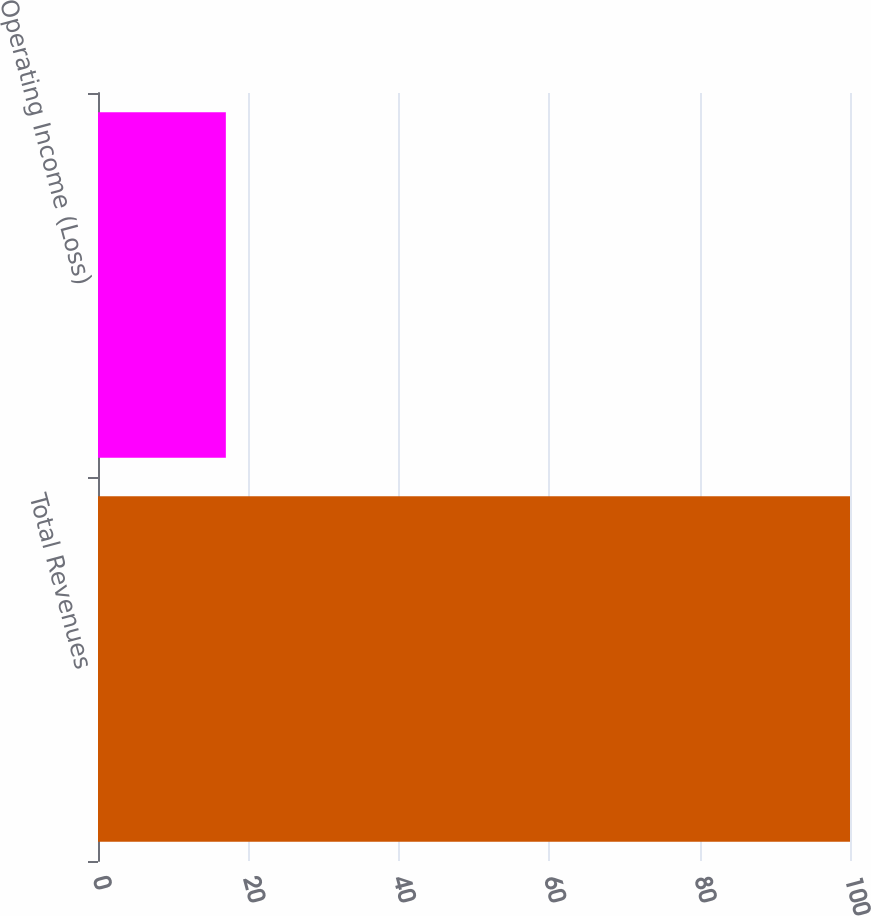Convert chart. <chart><loc_0><loc_0><loc_500><loc_500><bar_chart><fcel>Total Revenues<fcel>Operating Income (Loss)<nl><fcel>100<fcel>17<nl></chart> 